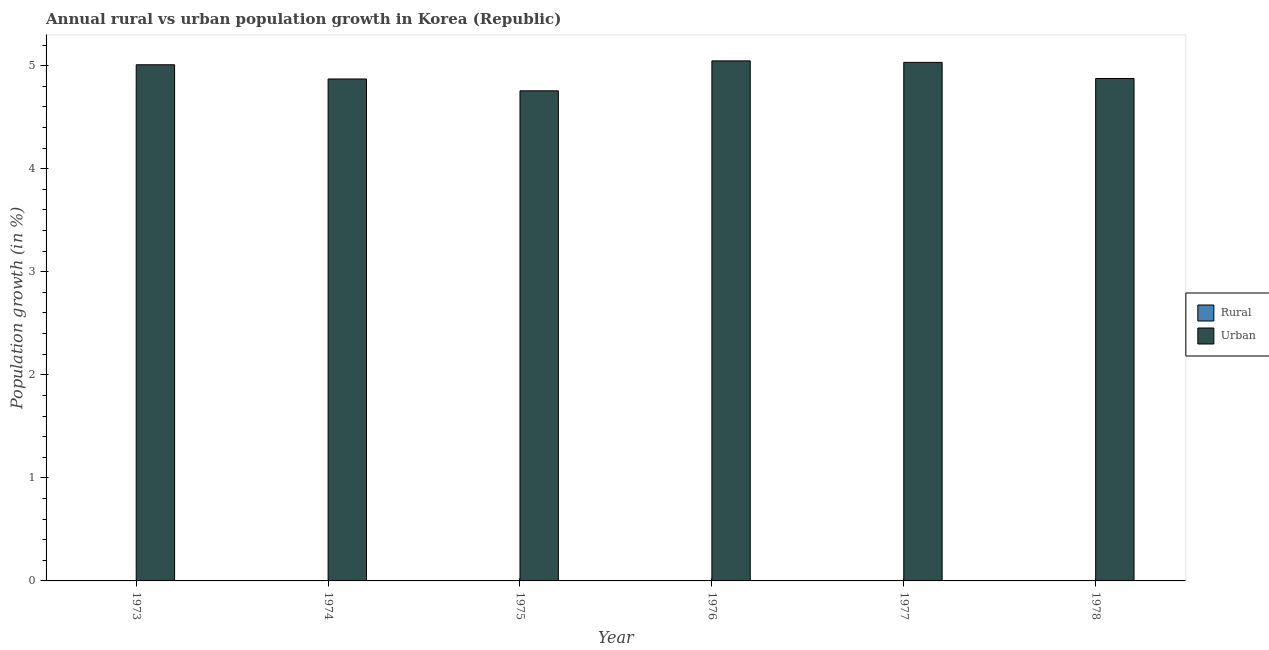How many different coloured bars are there?
Keep it short and to the point. 1. Are the number of bars on each tick of the X-axis equal?
Keep it short and to the point. Yes. How many bars are there on the 4th tick from the left?
Make the answer very short. 1. How many bars are there on the 1st tick from the right?
Give a very brief answer. 1. What is the label of the 5th group of bars from the left?
Provide a short and direct response. 1977. Across all years, what is the maximum urban population growth?
Your response must be concise. 5.05. In which year was the urban population growth maximum?
Your response must be concise. 1976. What is the total urban population growth in the graph?
Offer a very short reply. 29.59. What is the difference between the urban population growth in 1974 and that in 1976?
Give a very brief answer. -0.18. In the year 1974, what is the difference between the urban population growth and rural population growth?
Ensure brevity in your answer.  0. In how many years, is the rural population growth greater than 3.2 %?
Provide a succinct answer. 0. What is the ratio of the urban population growth in 1975 to that in 1978?
Make the answer very short. 0.98. Is the urban population growth in 1975 less than that in 1978?
Offer a very short reply. Yes. Is the difference between the urban population growth in 1976 and 1978 greater than the difference between the rural population growth in 1976 and 1978?
Your answer should be compact. No. What is the difference between the highest and the second highest urban population growth?
Provide a succinct answer. 0.01. What is the difference between the highest and the lowest urban population growth?
Ensure brevity in your answer.  0.29. Is the sum of the urban population growth in 1974 and 1977 greater than the maximum rural population growth across all years?
Your response must be concise. Yes. How many years are there in the graph?
Ensure brevity in your answer.  6. Does the graph contain any zero values?
Ensure brevity in your answer.  Yes. Does the graph contain grids?
Ensure brevity in your answer.  No. Where does the legend appear in the graph?
Offer a very short reply. Center right. How many legend labels are there?
Keep it short and to the point. 2. What is the title of the graph?
Your answer should be very brief. Annual rural vs urban population growth in Korea (Republic). What is the label or title of the Y-axis?
Keep it short and to the point. Population growth (in %). What is the Population growth (in %) of Urban  in 1973?
Provide a succinct answer. 5.01. What is the Population growth (in %) in Rural in 1974?
Your answer should be compact. 0. What is the Population growth (in %) in Urban  in 1974?
Your answer should be compact. 4.87. What is the Population growth (in %) in Rural in 1975?
Offer a terse response. 0. What is the Population growth (in %) of Urban  in 1975?
Make the answer very short. 4.76. What is the Population growth (in %) in Rural in 1976?
Offer a very short reply. 0. What is the Population growth (in %) of Urban  in 1976?
Make the answer very short. 5.05. What is the Population growth (in %) of Urban  in 1977?
Offer a terse response. 5.03. What is the Population growth (in %) in Urban  in 1978?
Your answer should be very brief. 4.88. Across all years, what is the maximum Population growth (in %) of Urban ?
Your response must be concise. 5.05. Across all years, what is the minimum Population growth (in %) in Urban ?
Offer a terse response. 4.76. What is the total Population growth (in %) in Urban  in the graph?
Provide a short and direct response. 29.59. What is the difference between the Population growth (in %) in Urban  in 1973 and that in 1974?
Your answer should be compact. 0.14. What is the difference between the Population growth (in %) in Urban  in 1973 and that in 1975?
Offer a very short reply. 0.25. What is the difference between the Population growth (in %) of Urban  in 1973 and that in 1976?
Provide a succinct answer. -0.04. What is the difference between the Population growth (in %) in Urban  in 1973 and that in 1977?
Offer a very short reply. -0.02. What is the difference between the Population growth (in %) of Urban  in 1973 and that in 1978?
Your answer should be compact. 0.13. What is the difference between the Population growth (in %) in Urban  in 1974 and that in 1975?
Make the answer very short. 0.11. What is the difference between the Population growth (in %) of Urban  in 1974 and that in 1976?
Provide a short and direct response. -0.18. What is the difference between the Population growth (in %) of Urban  in 1974 and that in 1977?
Your answer should be very brief. -0.16. What is the difference between the Population growth (in %) in Urban  in 1974 and that in 1978?
Provide a succinct answer. -0. What is the difference between the Population growth (in %) of Urban  in 1975 and that in 1976?
Make the answer very short. -0.29. What is the difference between the Population growth (in %) in Urban  in 1975 and that in 1977?
Keep it short and to the point. -0.28. What is the difference between the Population growth (in %) of Urban  in 1975 and that in 1978?
Offer a very short reply. -0.12. What is the difference between the Population growth (in %) in Urban  in 1976 and that in 1977?
Keep it short and to the point. 0.01. What is the difference between the Population growth (in %) of Urban  in 1976 and that in 1978?
Provide a succinct answer. 0.17. What is the difference between the Population growth (in %) in Urban  in 1977 and that in 1978?
Your response must be concise. 0.16. What is the average Population growth (in %) in Rural per year?
Give a very brief answer. 0. What is the average Population growth (in %) in Urban  per year?
Give a very brief answer. 4.93. What is the ratio of the Population growth (in %) in Urban  in 1973 to that in 1974?
Provide a short and direct response. 1.03. What is the ratio of the Population growth (in %) of Urban  in 1973 to that in 1975?
Your answer should be compact. 1.05. What is the ratio of the Population growth (in %) of Urban  in 1973 to that in 1978?
Give a very brief answer. 1.03. What is the ratio of the Population growth (in %) in Urban  in 1974 to that in 1975?
Keep it short and to the point. 1.02. What is the ratio of the Population growth (in %) of Urban  in 1974 to that in 1976?
Ensure brevity in your answer.  0.97. What is the ratio of the Population growth (in %) of Urban  in 1974 to that in 1977?
Ensure brevity in your answer.  0.97. What is the ratio of the Population growth (in %) of Urban  in 1975 to that in 1976?
Ensure brevity in your answer.  0.94. What is the ratio of the Population growth (in %) in Urban  in 1975 to that in 1977?
Ensure brevity in your answer.  0.95. What is the ratio of the Population growth (in %) of Urban  in 1975 to that in 1978?
Your answer should be very brief. 0.98. What is the ratio of the Population growth (in %) of Urban  in 1976 to that in 1977?
Your answer should be very brief. 1. What is the ratio of the Population growth (in %) of Urban  in 1976 to that in 1978?
Ensure brevity in your answer.  1.04. What is the ratio of the Population growth (in %) of Urban  in 1977 to that in 1978?
Offer a terse response. 1.03. What is the difference between the highest and the second highest Population growth (in %) of Urban ?
Your response must be concise. 0.01. What is the difference between the highest and the lowest Population growth (in %) of Urban ?
Provide a succinct answer. 0.29. 